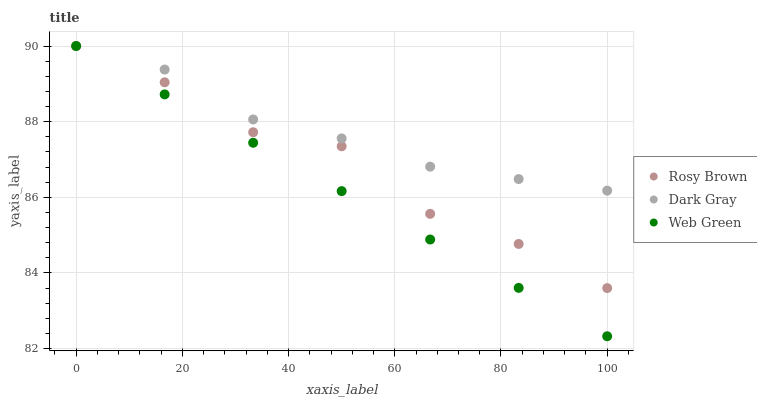Does Web Green have the minimum area under the curve?
Answer yes or no. Yes. Does Dark Gray have the maximum area under the curve?
Answer yes or no. Yes. Does Rosy Brown have the minimum area under the curve?
Answer yes or no. No. Does Rosy Brown have the maximum area under the curve?
Answer yes or no. No. Is Web Green the smoothest?
Answer yes or no. Yes. Is Rosy Brown the roughest?
Answer yes or no. Yes. Is Rosy Brown the smoothest?
Answer yes or no. No. Is Web Green the roughest?
Answer yes or no. No. Does Web Green have the lowest value?
Answer yes or no. Yes. Does Rosy Brown have the lowest value?
Answer yes or no. No. Does Web Green have the highest value?
Answer yes or no. Yes. Does Web Green intersect Dark Gray?
Answer yes or no. Yes. Is Web Green less than Dark Gray?
Answer yes or no. No. Is Web Green greater than Dark Gray?
Answer yes or no. No. 